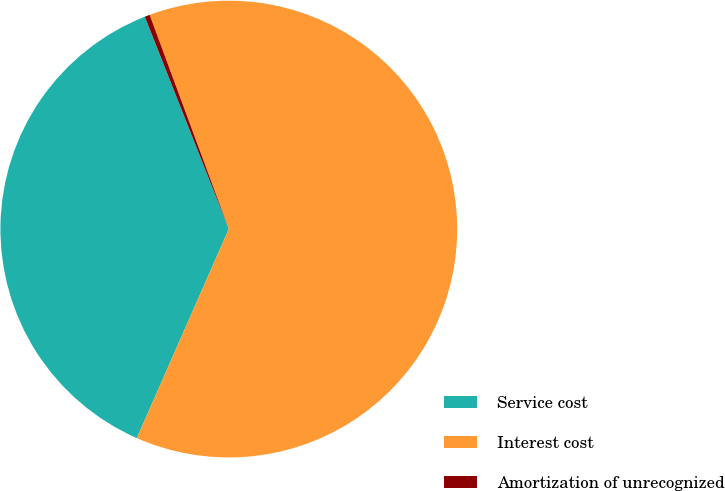<chart> <loc_0><loc_0><loc_500><loc_500><pie_chart><fcel>Service cost<fcel>Interest cost<fcel>Amortization of unrecognized<nl><fcel>37.41%<fcel>62.23%<fcel>0.36%<nl></chart> 